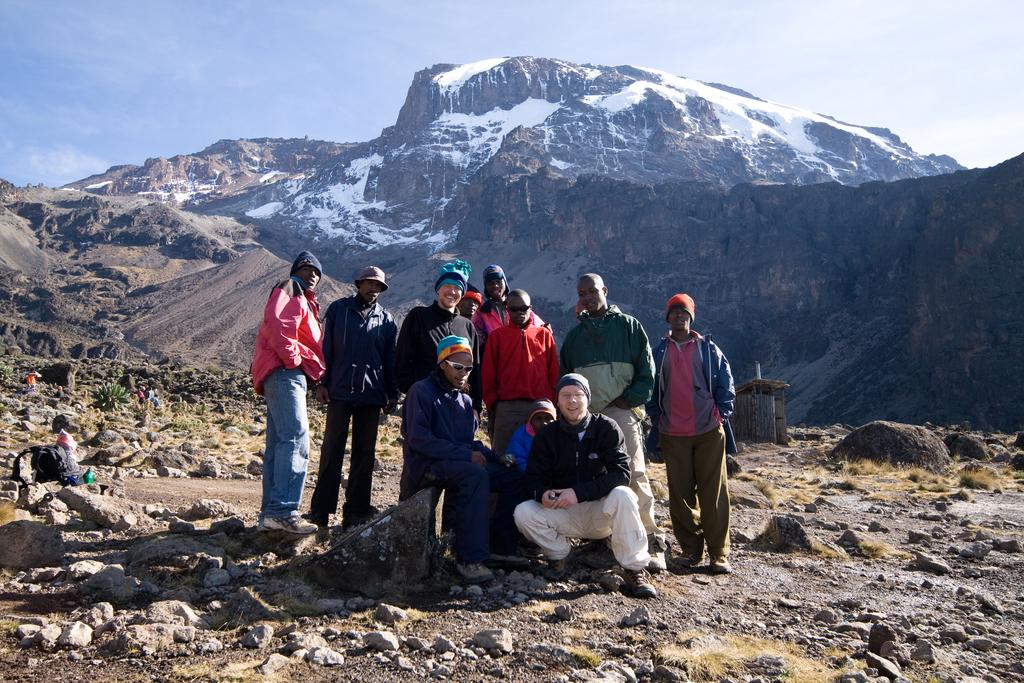How many people are in the image? There is a group of people in the image, but the exact number cannot be determined from the provided facts. What can be seen in the background of the image? There are hills with snow in the background of the image. What is visible in the sky at the top of the image? Clouds are visible in the sky at the top of the image. Where is the sofa located in the image? There is no sofa present in the image. What type of underwear is being worn by the people in the image? There is no information about the clothing of the people in the image, so it cannot be determined what type of underwear they might be wearing. 